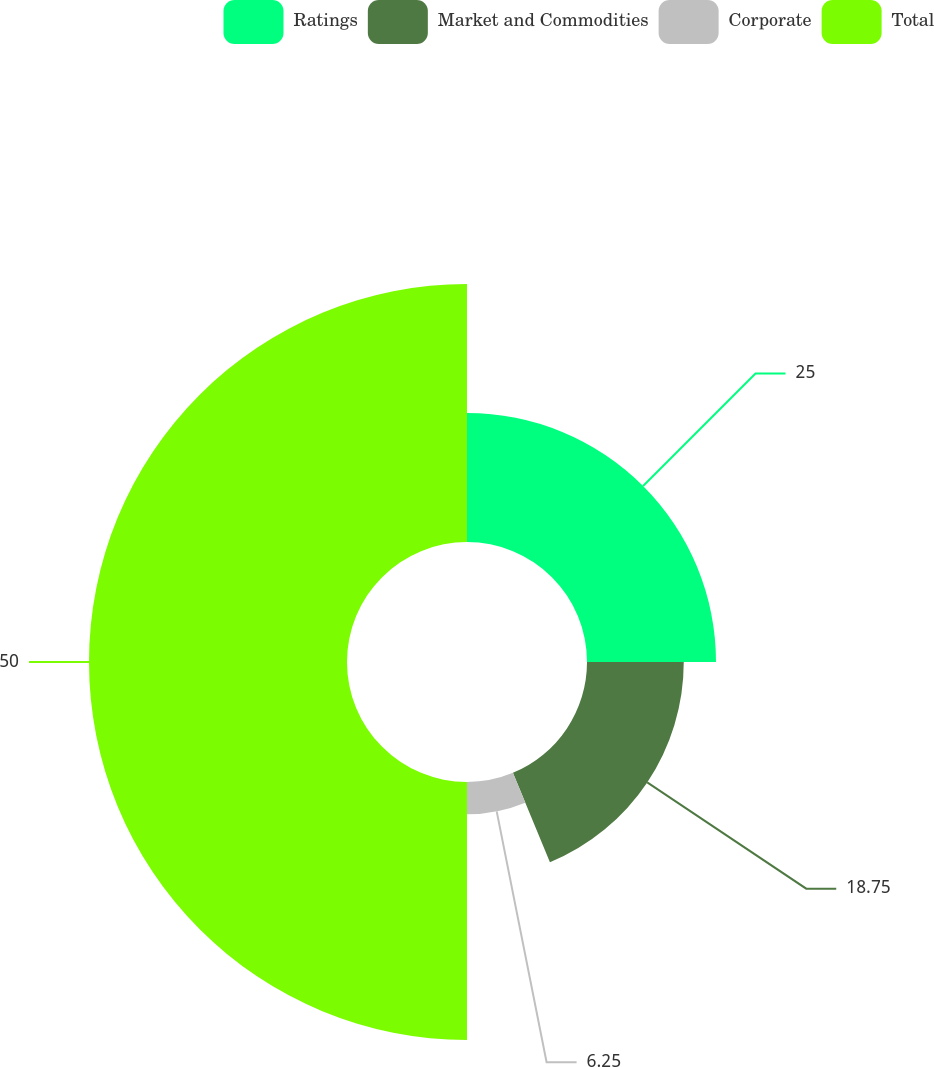Convert chart to OTSL. <chart><loc_0><loc_0><loc_500><loc_500><pie_chart><fcel>Ratings<fcel>Market and Commodities<fcel>Corporate<fcel>Total<nl><fcel>25.0%<fcel>18.75%<fcel>6.25%<fcel>50.0%<nl></chart> 